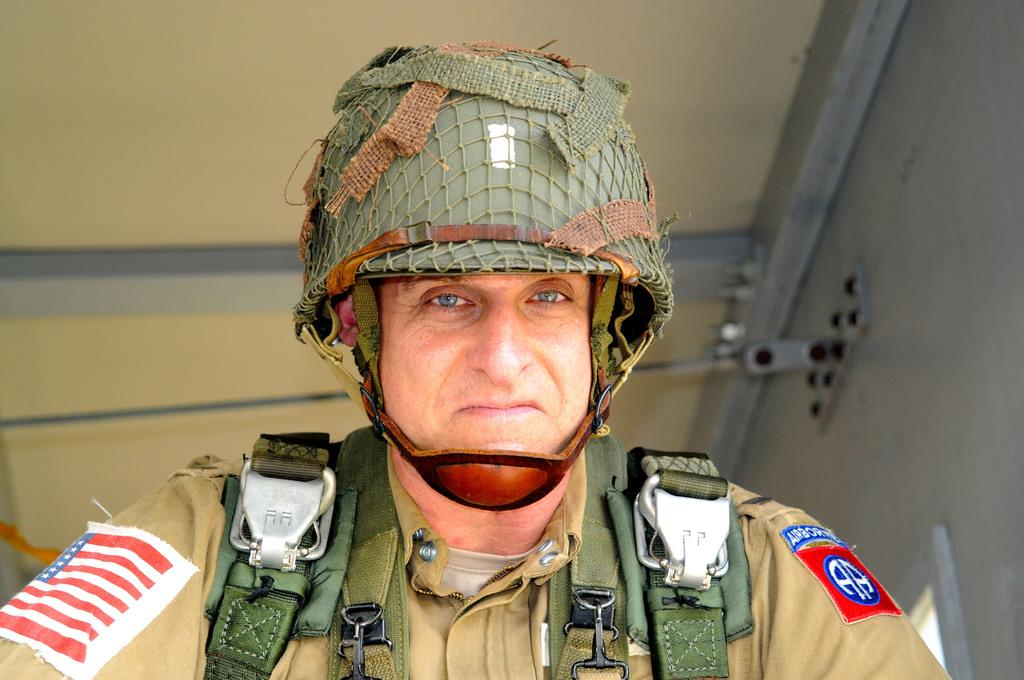What is present in the image? There is a man in the image. What is the man wearing on his head? The man is wearing a helmet. What type of structure is visible in the image? There is a wall and a roof visible in the image. Can you see any rats running around the man in the image? There are no rats visible in the image. How many passengers are there in the image? There is no reference to passengers in the image; it only features a man wearing a helmet. 